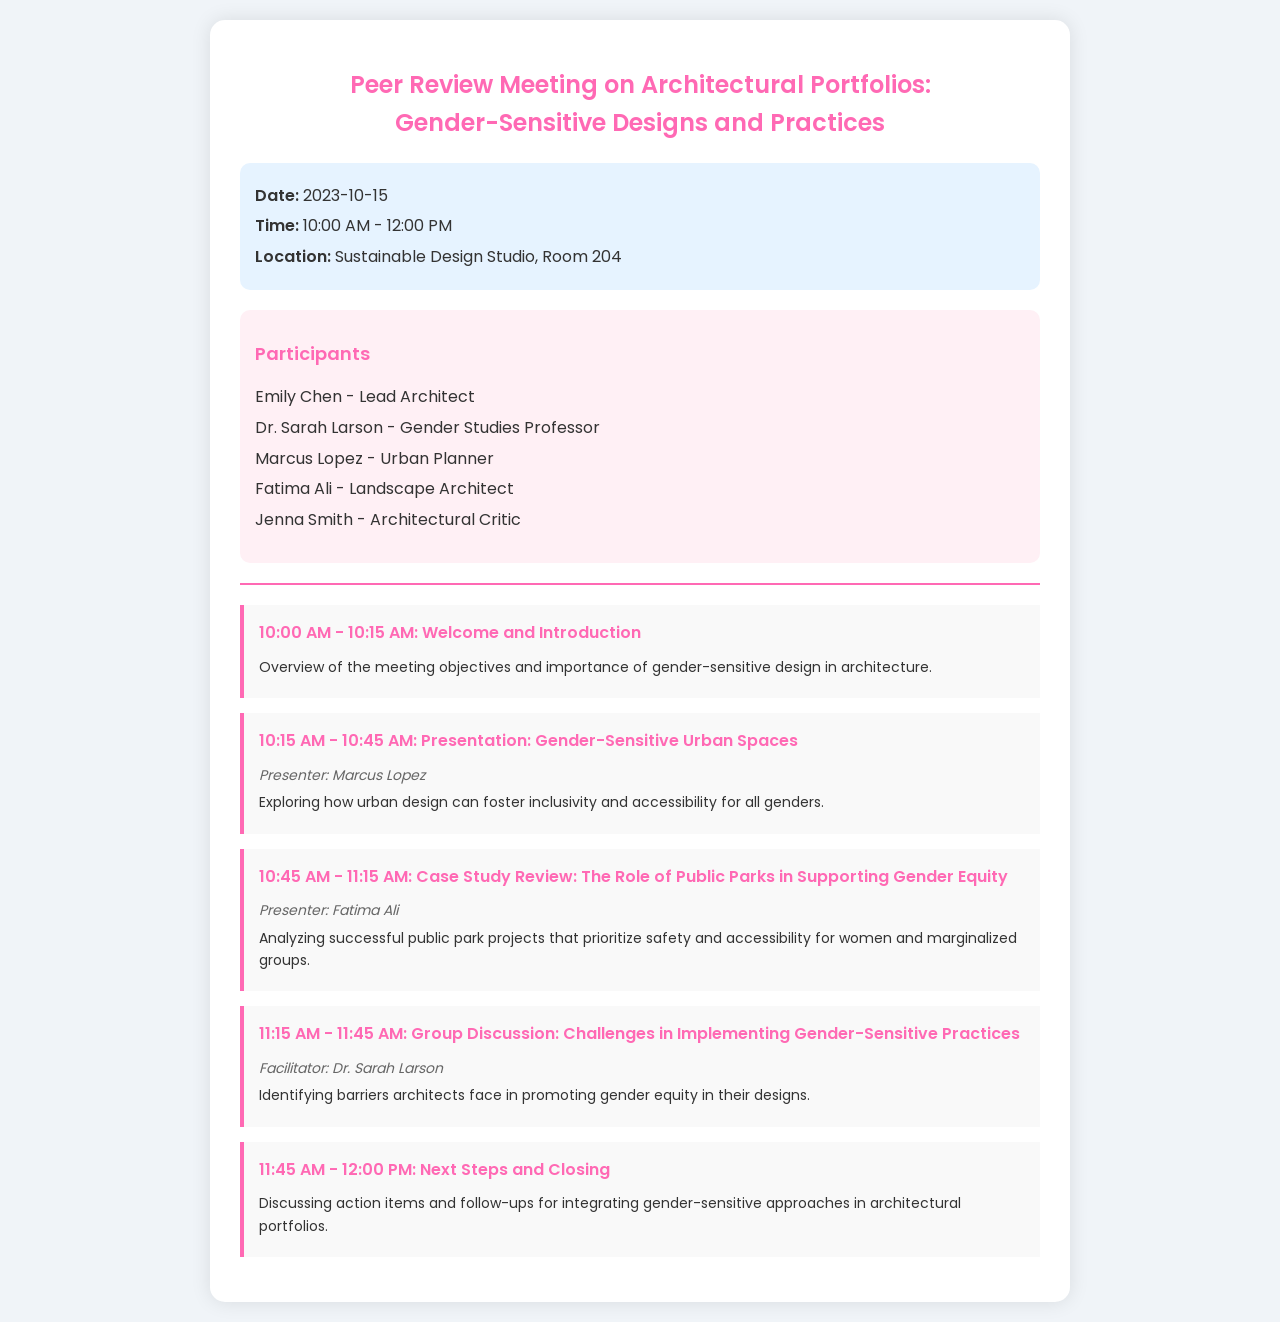what is the date of the meeting? The date is explicitly mentioned in the document under the meeting info section.
Answer: 2023-10-15 who is the presenter for the case study review? The document lists presenters for each schedule item, specifically highlighting who is presenting the case study review.
Answer: Fatima Ali what time does the meeting start? The starting time is clearly stated in the meeting info section of the document.
Answer: 10:00 AM how long is the group discussion scheduled to last? The duration can be determined by looking at the scheduled time frame for the group discussion in the schedule section.
Answer: 30 minutes who facilitates the group discussion? The facilitator is noted next to the group discussion schedule item in the document.
Answer: Dr. Sarah Larson what type of design practices is the meeting focusing on? The title of the meeting indicates the primary focus.
Answer: Gender-Sensitive Designs what is one of the main objectives of the presentation by Marcus Lopez? The document provides the purpose of the presentation under the schedule item.
Answer: Foster inclusivity how many participants are listed in the document? The total number of persons listed in the participants section can be counted directly from the list.
Answer: 5 